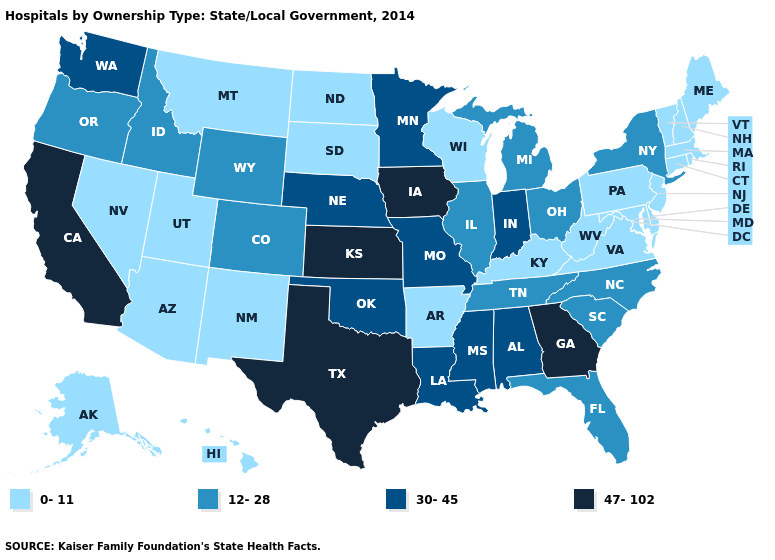Among the states that border Arkansas , does Texas have the highest value?
Keep it brief. Yes. What is the value of Alabama?
Answer briefly. 30-45. Name the states that have a value in the range 47-102?
Answer briefly. California, Georgia, Iowa, Kansas, Texas. Does the map have missing data?
Be succinct. No. Does the first symbol in the legend represent the smallest category?
Short answer required. Yes. What is the value of Louisiana?
Concise answer only. 30-45. What is the lowest value in states that border Colorado?
Be succinct. 0-11. Name the states that have a value in the range 0-11?
Concise answer only. Alaska, Arizona, Arkansas, Connecticut, Delaware, Hawaii, Kentucky, Maine, Maryland, Massachusetts, Montana, Nevada, New Hampshire, New Jersey, New Mexico, North Dakota, Pennsylvania, Rhode Island, South Dakota, Utah, Vermont, Virginia, West Virginia, Wisconsin. What is the value of North Carolina?
Answer briefly. 12-28. Name the states that have a value in the range 30-45?
Short answer required. Alabama, Indiana, Louisiana, Minnesota, Mississippi, Missouri, Nebraska, Oklahoma, Washington. Does the map have missing data?
Concise answer only. No. Name the states that have a value in the range 0-11?
Keep it brief. Alaska, Arizona, Arkansas, Connecticut, Delaware, Hawaii, Kentucky, Maine, Maryland, Massachusetts, Montana, Nevada, New Hampshire, New Jersey, New Mexico, North Dakota, Pennsylvania, Rhode Island, South Dakota, Utah, Vermont, Virginia, West Virginia, Wisconsin. Does the map have missing data?
Quick response, please. No. Name the states that have a value in the range 47-102?
Short answer required. California, Georgia, Iowa, Kansas, Texas. 